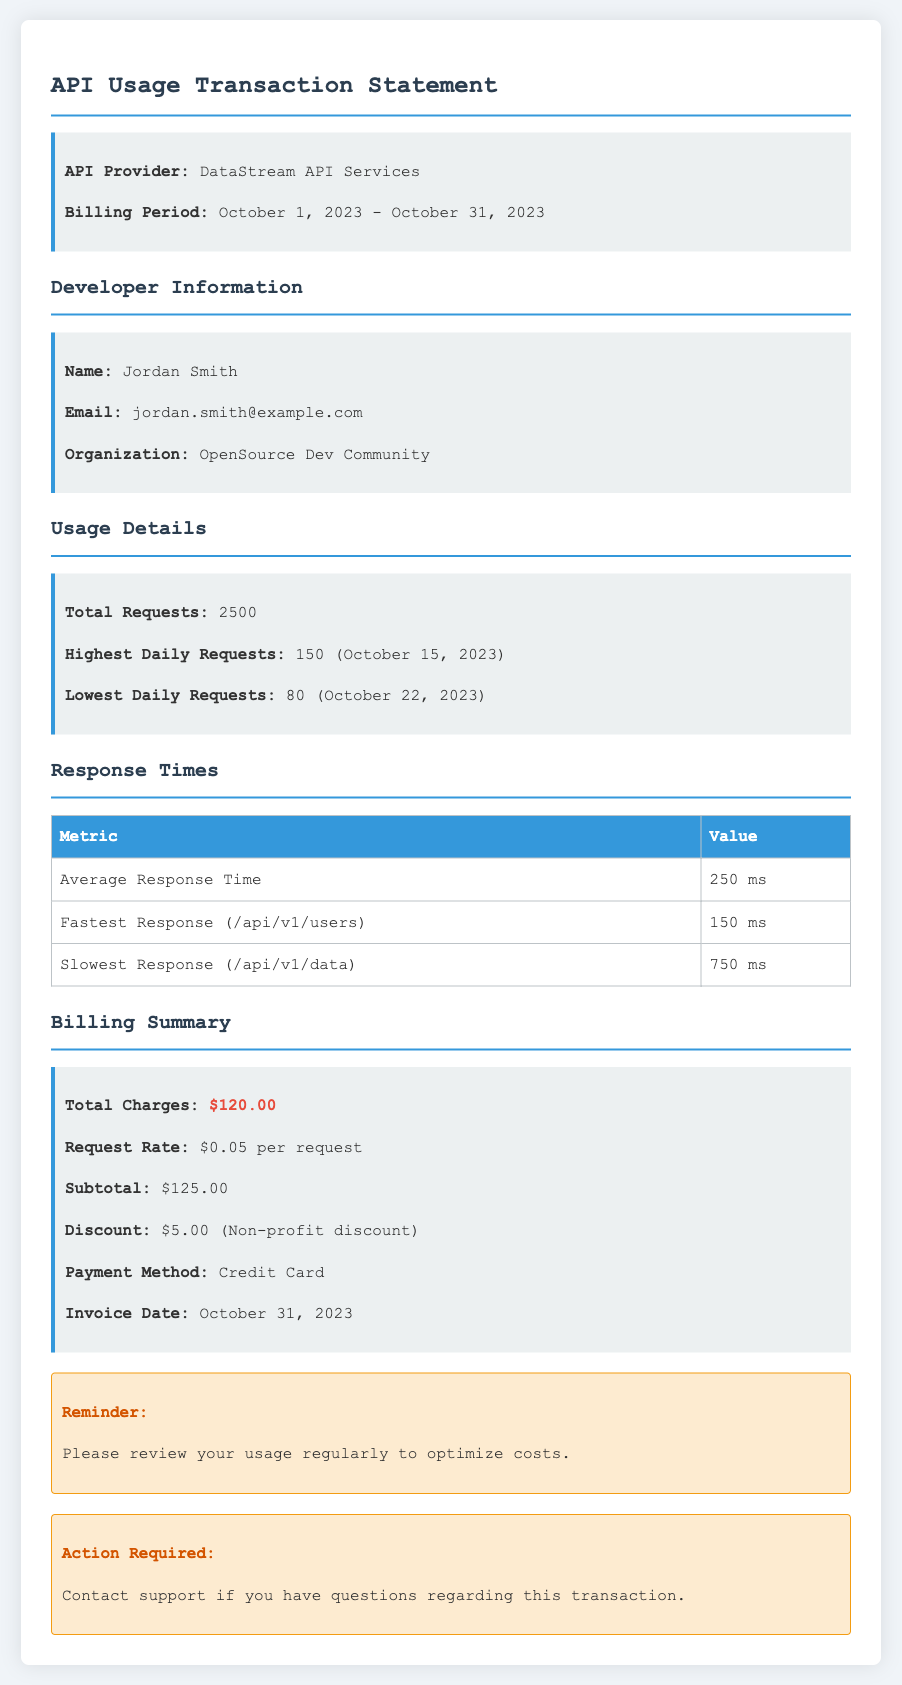what is the total number of requests? The document states the total requests made during the billing period, which is 2500.
Answer: 2500 who is the developer? The document provides the name of the developer responsible for the usage, which is Jordan Smith.
Answer: Jordan Smith what is the average response time? The average response time is explicitly mentioned in the document, which is 250 ms.
Answer: 250 ms what was the highest daily requests and on what date? The document specifies that the highest daily requests were 150 on October 15, 2023.
Answer: 150 (October 15, 2023) what is the total charges for the billing period? The total charges for the billing period are summarized in the document as $120.00.
Answer: $120.00 what discount was applied? The document mentions a discount of $5.00 for a specific reason, which is categorized as a non-profit discount.
Answer: $5.00 (Non-profit discount) who is the API provider? The document clearly states the entity providing the API service, which is DataStream API Services.
Answer: DataStream API Services what was the lowest daily requests and on what date? The lowest daily requests are specified in the document as 80 on October 22, 2023.
Answer: 80 (October 22, 2023) what payment method was used? The document indicates the method used for payment, which is a Credit Card.
Answer: Credit Card 